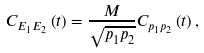<formula> <loc_0><loc_0><loc_500><loc_500>C _ { E _ { 1 } E _ { 2 } } \left ( t \right ) = \frac { M } { \sqrt { p _ { 1 } p _ { 2 } } } C _ { p _ { 1 } p _ { 2 } } \left ( t \right ) ,</formula> 